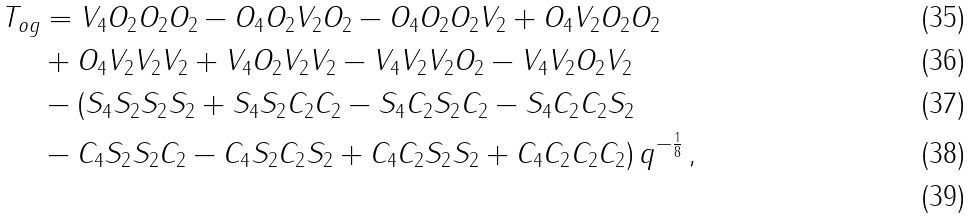<formula> <loc_0><loc_0><loc_500><loc_500>T _ { o g } & = V _ { 4 } O _ { 2 } O _ { 2 } O _ { 2 } - O _ { 4 } O _ { 2 } V _ { 2 } O _ { 2 } - O _ { 4 } O _ { 2 } O _ { 2 } V _ { 2 } + O _ { 4 } V _ { 2 } O _ { 2 } O _ { 2 } \\ & + O _ { 4 } V _ { 2 } V _ { 2 } V _ { 2 } + V _ { 4 } O _ { 2 } V _ { 2 } V _ { 2 } - V _ { 4 } V _ { 2 } V _ { 2 } O _ { 2 } - V _ { 4 } V _ { 2 } O _ { 2 } V _ { 2 } \\ & - ( S _ { 4 } S _ { 2 } S _ { 2 } S _ { 2 } + S _ { 4 } S _ { 2 } C _ { 2 } C _ { 2 } - S _ { 4 } C _ { 2 } S _ { 2 } C _ { 2 } - S _ { 4 } C _ { 2 } C _ { 2 } S _ { 2 } \\ & - C _ { 4 } S _ { 2 } S _ { 2 } C _ { 2 } - C _ { 4 } S _ { 2 } C _ { 2 } S _ { 2 } + C _ { 4 } C _ { 2 } S _ { 2 } S _ { 2 } + C _ { 4 } C _ { 2 } C _ { 2 } C _ { 2 } ) \, q ^ { - \frac { 1 } { 8 } } \, , \\</formula> 